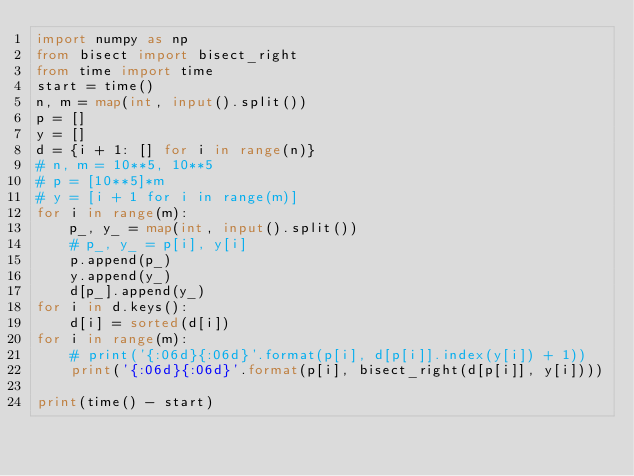Convert code to text. <code><loc_0><loc_0><loc_500><loc_500><_Python_>import numpy as np
from bisect import bisect_right
from time import time
start = time()
n, m = map(int, input().split())
p = []
y = []
d = {i + 1: [] for i in range(n)}
# n, m = 10**5, 10**5
# p = [10**5]*m
# y = [i + 1 for i in range(m)]
for i in range(m):
    p_, y_ = map(int, input().split())
    # p_, y_ = p[i], y[i]
    p.append(p_)
    y.append(y_)
    d[p_].append(y_)
for i in d.keys():
    d[i] = sorted(d[i])
for i in range(m):
    # print('{:06d}{:06d}'.format(p[i], d[p[i]].index(y[i]) + 1))
    print('{:06d}{:06d}'.format(p[i], bisect_right(d[p[i]], y[i])))

print(time() - start)
</code> 